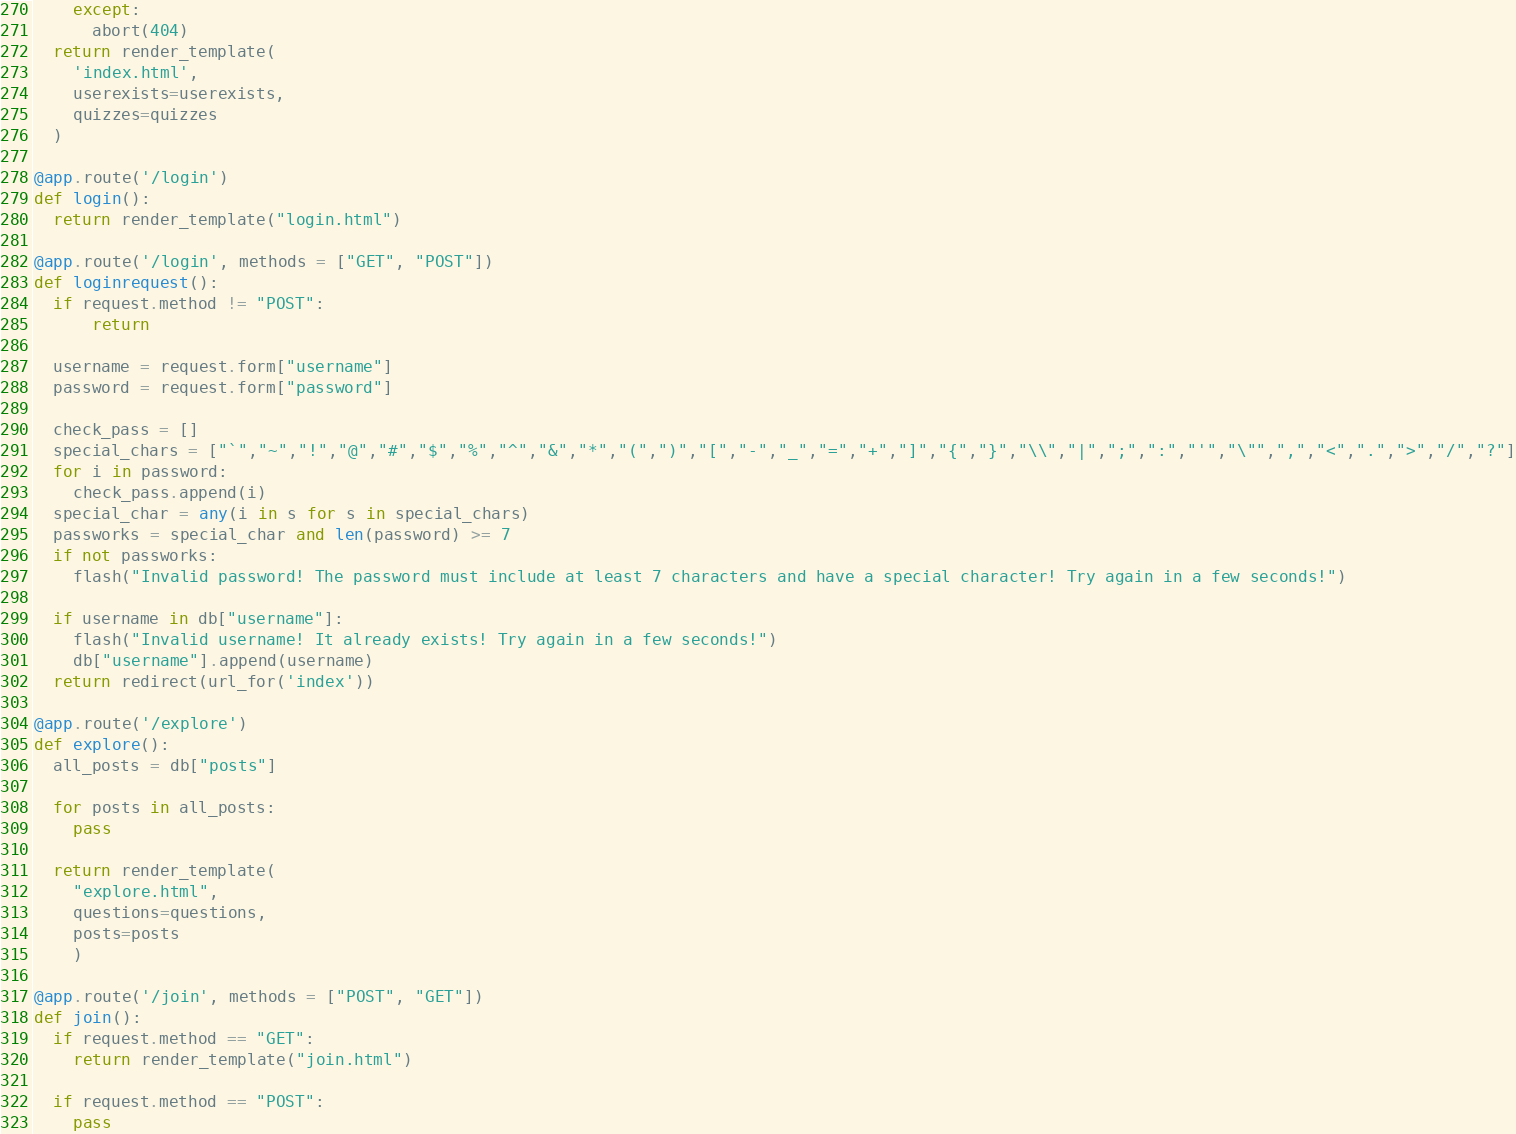<code> <loc_0><loc_0><loc_500><loc_500><_Python_>    except:
      abort(404)
  return render_template(
    'index.html',
    userexists=userexists,
    quizzes=quizzes
  )

@app.route('/login')
def login():
  return render_template("login.html")

@app.route('/login', methods = ["GET", "POST"])
def loginrequest():
  if request.method != "POST":
      return

  username = request.form["username"]
  password = request.form["password"]

  check_pass = []
  special_chars = ["`","~","!","@","#","$","%","^","&","*","(",")","[","-","_","=","+","]","{","}","\\","|",";",":","'","\"",",","<",".",">","/","?"]
  for i in password:
    check_pass.append(i)
  special_char = any(i in s for s in special_chars)
  passworks = special_char and len(password) >= 7
  if not passworks:
    flash("Invalid password! The password must include at least 7 characters and have a special character! Try again in a few seconds!")

  if username in db["username"]:
    flash("Invalid username! It already exists! Try again in a few seconds!")
    db["username"].append(username)
  return redirect(url_for('index'))

@app.route('/explore')
def explore():
  all_posts = db["posts"]

  for posts in all_posts:
    pass
  
  return render_template(
    "explore.html",
    questions=questions,
    posts=posts
    )

@app.route('/join', methods = ["POST", "GET"])
def join():
  if request.method == "GET":
    return render_template("join.html")
  
  if request.method == "POST":
    pass
</code> 